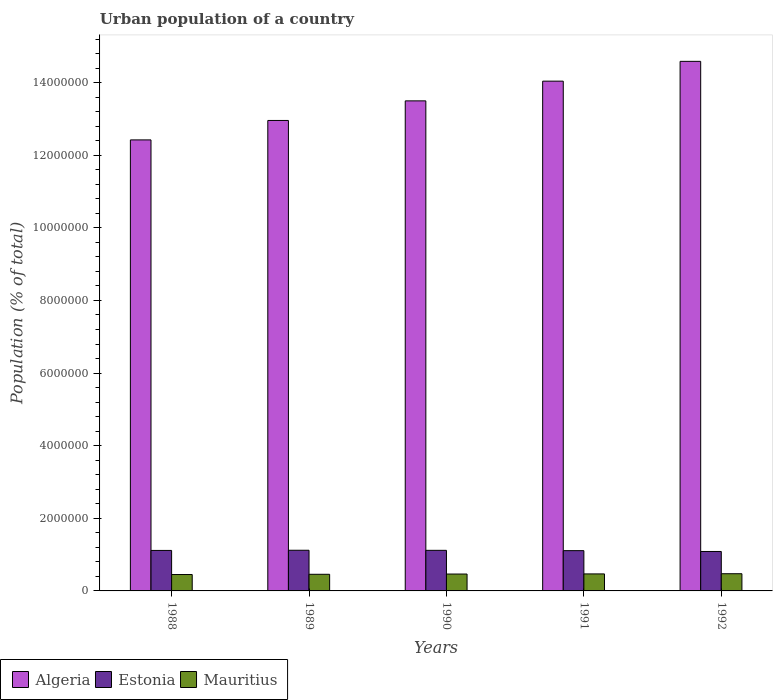How many different coloured bars are there?
Your response must be concise. 3. How many groups of bars are there?
Ensure brevity in your answer.  5. Are the number of bars on each tick of the X-axis equal?
Offer a very short reply. Yes. How many bars are there on the 4th tick from the right?
Provide a succinct answer. 3. What is the label of the 5th group of bars from the left?
Your response must be concise. 1992. What is the urban population in Mauritius in 1992?
Give a very brief answer. 4.73e+05. Across all years, what is the maximum urban population in Algeria?
Provide a short and direct response. 1.46e+07. Across all years, what is the minimum urban population in Algeria?
Ensure brevity in your answer.  1.24e+07. In which year was the urban population in Mauritius minimum?
Your response must be concise. 1988. What is the total urban population in Mauritius in the graph?
Offer a very short reply. 2.32e+06. What is the difference between the urban population in Estonia in 1989 and that in 1990?
Ensure brevity in your answer.  2143. What is the difference between the urban population in Estonia in 1988 and the urban population in Algeria in 1992?
Your answer should be compact. -1.35e+07. What is the average urban population in Mauritius per year?
Ensure brevity in your answer.  4.63e+05. In the year 1988, what is the difference between the urban population in Algeria and urban population in Mauritius?
Your response must be concise. 1.20e+07. In how many years, is the urban population in Algeria greater than 13200000 %?
Provide a succinct answer. 3. What is the ratio of the urban population in Mauritius in 1991 to that in 1992?
Provide a succinct answer. 0.99. Is the urban population in Mauritius in 1990 less than that in 1991?
Provide a succinct answer. Yes. Is the difference between the urban population in Algeria in 1990 and 1992 greater than the difference between the urban population in Mauritius in 1990 and 1992?
Your response must be concise. No. What is the difference between the highest and the second highest urban population in Mauritius?
Your response must be concise. 4861. What is the difference between the highest and the lowest urban population in Estonia?
Give a very brief answer. 3.35e+04. Is the sum of the urban population in Algeria in 1989 and 1990 greater than the maximum urban population in Estonia across all years?
Offer a very short reply. Yes. What does the 1st bar from the left in 1992 represents?
Your response must be concise. Algeria. What does the 2nd bar from the right in 1991 represents?
Offer a terse response. Estonia. Is it the case that in every year, the sum of the urban population in Algeria and urban population in Estonia is greater than the urban population in Mauritius?
Offer a very short reply. Yes. Are all the bars in the graph horizontal?
Provide a short and direct response. No. How many years are there in the graph?
Your answer should be very brief. 5. Are the values on the major ticks of Y-axis written in scientific E-notation?
Provide a succinct answer. No. Where does the legend appear in the graph?
Keep it short and to the point. Bottom left. How many legend labels are there?
Ensure brevity in your answer.  3. How are the legend labels stacked?
Offer a very short reply. Horizontal. What is the title of the graph?
Provide a short and direct response. Urban population of a country. Does "South Asia" appear as one of the legend labels in the graph?
Offer a terse response. No. What is the label or title of the X-axis?
Ensure brevity in your answer.  Years. What is the label or title of the Y-axis?
Your answer should be compact. Population (% of total). What is the Population (% of total) of Algeria in 1988?
Give a very brief answer. 1.24e+07. What is the Population (% of total) in Estonia in 1988?
Offer a very short reply. 1.12e+06. What is the Population (% of total) in Mauritius in 1988?
Offer a terse response. 4.51e+05. What is the Population (% of total) of Algeria in 1989?
Offer a terse response. 1.30e+07. What is the Population (% of total) of Estonia in 1989?
Your answer should be compact. 1.12e+06. What is the Population (% of total) in Mauritius in 1989?
Give a very brief answer. 4.58e+05. What is the Population (% of total) in Algeria in 1990?
Ensure brevity in your answer.  1.35e+07. What is the Population (% of total) of Estonia in 1990?
Offer a terse response. 1.12e+06. What is the Population (% of total) in Mauritius in 1990?
Ensure brevity in your answer.  4.65e+05. What is the Population (% of total) in Algeria in 1991?
Provide a succinct answer. 1.40e+07. What is the Population (% of total) of Estonia in 1991?
Offer a terse response. 1.11e+06. What is the Population (% of total) in Mauritius in 1991?
Ensure brevity in your answer.  4.69e+05. What is the Population (% of total) in Algeria in 1992?
Your response must be concise. 1.46e+07. What is the Population (% of total) of Estonia in 1992?
Your answer should be very brief. 1.09e+06. What is the Population (% of total) in Mauritius in 1992?
Your answer should be compact. 4.73e+05. Across all years, what is the maximum Population (% of total) in Algeria?
Keep it short and to the point. 1.46e+07. Across all years, what is the maximum Population (% of total) of Estonia?
Keep it short and to the point. 1.12e+06. Across all years, what is the maximum Population (% of total) in Mauritius?
Provide a succinct answer. 4.73e+05. Across all years, what is the minimum Population (% of total) of Algeria?
Make the answer very short. 1.24e+07. Across all years, what is the minimum Population (% of total) in Estonia?
Offer a terse response. 1.09e+06. Across all years, what is the minimum Population (% of total) of Mauritius?
Offer a terse response. 4.51e+05. What is the total Population (% of total) of Algeria in the graph?
Make the answer very short. 6.75e+07. What is the total Population (% of total) of Estonia in the graph?
Give a very brief answer. 5.55e+06. What is the total Population (% of total) of Mauritius in the graph?
Offer a terse response. 2.32e+06. What is the difference between the Population (% of total) of Algeria in 1988 and that in 1989?
Ensure brevity in your answer.  -5.35e+05. What is the difference between the Population (% of total) in Estonia in 1988 and that in 1989?
Offer a very short reply. -4841. What is the difference between the Population (% of total) of Mauritius in 1988 and that in 1989?
Provide a short and direct response. -6782. What is the difference between the Population (% of total) in Algeria in 1988 and that in 1990?
Keep it short and to the point. -1.08e+06. What is the difference between the Population (% of total) in Estonia in 1988 and that in 1990?
Provide a short and direct response. -2698. What is the difference between the Population (% of total) in Mauritius in 1988 and that in 1990?
Your answer should be very brief. -1.34e+04. What is the difference between the Population (% of total) in Algeria in 1988 and that in 1991?
Offer a terse response. -1.62e+06. What is the difference between the Population (% of total) in Estonia in 1988 and that in 1991?
Your answer should be very brief. 5789. What is the difference between the Population (% of total) of Mauritius in 1988 and that in 1991?
Give a very brief answer. -1.71e+04. What is the difference between the Population (% of total) of Algeria in 1988 and that in 1992?
Your response must be concise. -2.16e+06. What is the difference between the Population (% of total) in Estonia in 1988 and that in 1992?
Offer a very short reply. 2.87e+04. What is the difference between the Population (% of total) in Mauritius in 1988 and that in 1992?
Your answer should be compact. -2.20e+04. What is the difference between the Population (% of total) in Algeria in 1989 and that in 1990?
Your response must be concise. -5.40e+05. What is the difference between the Population (% of total) of Estonia in 1989 and that in 1990?
Your response must be concise. 2143. What is the difference between the Population (% of total) in Mauritius in 1989 and that in 1990?
Give a very brief answer. -6621. What is the difference between the Population (% of total) in Algeria in 1989 and that in 1991?
Offer a terse response. -1.08e+06. What is the difference between the Population (% of total) of Estonia in 1989 and that in 1991?
Your response must be concise. 1.06e+04. What is the difference between the Population (% of total) in Mauritius in 1989 and that in 1991?
Offer a terse response. -1.03e+04. What is the difference between the Population (% of total) in Algeria in 1989 and that in 1992?
Your response must be concise. -1.63e+06. What is the difference between the Population (% of total) in Estonia in 1989 and that in 1992?
Give a very brief answer. 3.35e+04. What is the difference between the Population (% of total) of Mauritius in 1989 and that in 1992?
Give a very brief answer. -1.52e+04. What is the difference between the Population (% of total) of Algeria in 1990 and that in 1991?
Your answer should be very brief. -5.43e+05. What is the difference between the Population (% of total) in Estonia in 1990 and that in 1991?
Provide a short and direct response. 8487. What is the difference between the Population (% of total) in Mauritius in 1990 and that in 1991?
Offer a very short reply. -3728. What is the difference between the Population (% of total) in Algeria in 1990 and that in 1992?
Your answer should be very brief. -1.09e+06. What is the difference between the Population (% of total) of Estonia in 1990 and that in 1992?
Keep it short and to the point. 3.14e+04. What is the difference between the Population (% of total) of Mauritius in 1990 and that in 1992?
Give a very brief answer. -8589. What is the difference between the Population (% of total) of Algeria in 1991 and that in 1992?
Keep it short and to the point. -5.45e+05. What is the difference between the Population (% of total) of Estonia in 1991 and that in 1992?
Keep it short and to the point. 2.29e+04. What is the difference between the Population (% of total) in Mauritius in 1991 and that in 1992?
Provide a succinct answer. -4861. What is the difference between the Population (% of total) of Algeria in 1988 and the Population (% of total) of Estonia in 1989?
Provide a short and direct response. 1.13e+07. What is the difference between the Population (% of total) of Algeria in 1988 and the Population (% of total) of Mauritius in 1989?
Your response must be concise. 1.20e+07. What is the difference between the Population (% of total) in Estonia in 1988 and the Population (% of total) in Mauritius in 1989?
Provide a succinct answer. 6.57e+05. What is the difference between the Population (% of total) of Algeria in 1988 and the Population (% of total) of Estonia in 1990?
Provide a succinct answer. 1.13e+07. What is the difference between the Population (% of total) in Algeria in 1988 and the Population (% of total) in Mauritius in 1990?
Provide a succinct answer. 1.20e+07. What is the difference between the Population (% of total) of Estonia in 1988 and the Population (% of total) of Mauritius in 1990?
Give a very brief answer. 6.50e+05. What is the difference between the Population (% of total) of Algeria in 1988 and the Population (% of total) of Estonia in 1991?
Give a very brief answer. 1.13e+07. What is the difference between the Population (% of total) of Algeria in 1988 and the Population (% of total) of Mauritius in 1991?
Offer a very short reply. 1.20e+07. What is the difference between the Population (% of total) of Estonia in 1988 and the Population (% of total) of Mauritius in 1991?
Offer a very short reply. 6.47e+05. What is the difference between the Population (% of total) in Algeria in 1988 and the Population (% of total) in Estonia in 1992?
Provide a succinct answer. 1.13e+07. What is the difference between the Population (% of total) of Algeria in 1988 and the Population (% of total) of Mauritius in 1992?
Ensure brevity in your answer.  1.19e+07. What is the difference between the Population (% of total) of Estonia in 1988 and the Population (% of total) of Mauritius in 1992?
Provide a short and direct response. 6.42e+05. What is the difference between the Population (% of total) in Algeria in 1989 and the Population (% of total) in Estonia in 1990?
Give a very brief answer. 1.18e+07. What is the difference between the Population (% of total) in Algeria in 1989 and the Population (% of total) in Mauritius in 1990?
Provide a succinct answer. 1.25e+07. What is the difference between the Population (% of total) in Estonia in 1989 and the Population (% of total) in Mauritius in 1990?
Provide a succinct answer. 6.55e+05. What is the difference between the Population (% of total) in Algeria in 1989 and the Population (% of total) in Estonia in 1991?
Provide a short and direct response. 1.18e+07. What is the difference between the Population (% of total) of Algeria in 1989 and the Population (% of total) of Mauritius in 1991?
Your answer should be very brief. 1.25e+07. What is the difference between the Population (% of total) in Estonia in 1989 and the Population (% of total) in Mauritius in 1991?
Make the answer very short. 6.51e+05. What is the difference between the Population (% of total) in Algeria in 1989 and the Population (% of total) in Estonia in 1992?
Ensure brevity in your answer.  1.19e+07. What is the difference between the Population (% of total) in Algeria in 1989 and the Population (% of total) in Mauritius in 1992?
Provide a succinct answer. 1.25e+07. What is the difference between the Population (% of total) of Estonia in 1989 and the Population (% of total) of Mauritius in 1992?
Provide a short and direct response. 6.46e+05. What is the difference between the Population (% of total) in Algeria in 1990 and the Population (% of total) in Estonia in 1991?
Ensure brevity in your answer.  1.24e+07. What is the difference between the Population (% of total) in Algeria in 1990 and the Population (% of total) in Mauritius in 1991?
Give a very brief answer. 1.30e+07. What is the difference between the Population (% of total) of Estonia in 1990 and the Population (% of total) of Mauritius in 1991?
Your answer should be very brief. 6.49e+05. What is the difference between the Population (% of total) in Algeria in 1990 and the Population (% of total) in Estonia in 1992?
Give a very brief answer. 1.24e+07. What is the difference between the Population (% of total) of Algeria in 1990 and the Population (% of total) of Mauritius in 1992?
Offer a very short reply. 1.30e+07. What is the difference between the Population (% of total) of Estonia in 1990 and the Population (% of total) of Mauritius in 1992?
Provide a short and direct response. 6.44e+05. What is the difference between the Population (% of total) in Algeria in 1991 and the Population (% of total) in Estonia in 1992?
Provide a succinct answer. 1.30e+07. What is the difference between the Population (% of total) of Algeria in 1991 and the Population (% of total) of Mauritius in 1992?
Provide a short and direct response. 1.36e+07. What is the difference between the Population (% of total) in Estonia in 1991 and the Population (% of total) in Mauritius in 1992?
Your answer should be compact. 6.36e+05. What is the average Population (% of total) in Algeria per year?
Make the answer very short. 1.35e+07. What is the average Population (% of total) in Estonia per year?
Make the answer very short. 1.11e+06. What is the average Population (% of total) in Mauritius per year?
Ensure brevity in your answer.  4.63e+05. In the year 1988, what is the difference between the Population (% of total) of Algeria and Population (% of total) of Estonia?
Make the answer very short. 1.13e+07. In the year 1988, what is the difference between the Population (% of total) of Algeria and Population (% of total) of Mauritius?
Your answer should be compact. 1.20e+07. In the year 1988, what is the difference between the Population (% of total) in Estonia and Population (% of total) in Mauritius?
Your answer should be compact. 6.64e+05. In the year 1989, what is the difference between the Population (% of total) in Algeria and Population (% of total) in Estonia?
Make the answer very short. 1.18e+07. In the year 1989, what is the difference between the Population (% of total) of Algeria and Population (% of total) of Mauritius?
Provide a short and direct response. 1.25e+07. In the year 1989, what is the difference between the Population (% of total) in Estonia and Population (% of total) in Mauritius?
Your response must be concise. 6.62e+05. In the year 1990, what is the difference between the Population (% of total) in Algeria and Population (% of total) in Estonia?
Make the answer very short. 1.24e+07. In the year 1990, what is the difference between the Population (% of total) in Algeria and Population (% of total) in Mauritius?
Give a very brief answer. 1.30e+07. In the year 1990, what is the difference between the Population (% of total) of Estonia and Population (% of total) of Mauritius?
Provide a succinct answer. 6.53e+05. In the year 1991, what is the difference between the Population (% of total) in Algeria and Population (% of total) in Estonia?
Offer a terse response. 1.29e+07. In the year 1991, what is the difference between the Population (% of total) of Algeria and Population (% of total) of Mauritius?
Your response must be concise. 1.36e+07. In the year 1991, what is the difference between the Population (% of total) in Estonia and Population (% of total) in Mauritius?
Make the answer very short. 6.41e+05. In the year 1992, what is the difference between the Population (% of total) in Algeria and Population (% of total) in Estonia?
Your answer should be compact. 1.35e+07. In the year 1992, what is the difference between the Population (% of total) of Algeria and Population (% of total) of Mauritius?
Keep it short and to the point. 1.41e+07. In the year 1992, what is the difference between the Population (% of total) of Estonia and Population (% of total) of Mauritius?
Offer a very short reply. 6.13e+05. What is the ratio of the Population (% of total) of Algeria in 1988 to that in 1989?
Your answer should be compact. 0.96. What is the ratio of the Population (% of total) of Estonia in 1988 to that in 1989?
Offer a terse response. 1. What is the ratio of the Population (% of total) of Mauritius in 1988 to that in 1989?
Provide a succinct answer. 0.99. What is the ratio of the Population (% of total) in Algeria in 1988 to that in 1990?
Make the answer very short. 0.92. What is the ratio of the Population (% of total) in Estonia in 1988 to that in 1990?
Ensure brevity in your answer.  1. What is the ratio of the Population (% of total) in Mauritius in 1988 to that in 1990?
Make the answer very short. 0.97. What is the ratio of the Population (% of total) in Algeria in 1988 to that in 1991?
Your answer should be very brief. 0.88. What is the ratio of the Population (% of total) of Mauritius in 1988 to that in 1991?
Your response must be concise. 0.96. What is the ratio of the Population (% of total) of Algeria in 1988 to that in 1992?
Keep it short and to the point. 0.85. What is the ratio of the Population (% of total) of Estonia in 1988 to that in 1992?
Your response must be concise. 1.03. What is the ratio of the Population (% of total) in Mauritius in 1988 to that in 1992?
Provide a succinct answer. 0.95. What is the ratio of the Population (% of total) in Algeria in 1989 to that in 1990?
Give a very brief answer. 0.96. What is the ratio of the Population (% of total) of Estonia in 1989 to that in 1990?
Provide a short and direct response. 1. What is the ratio of the Population (% of total) in Mauritius in 1989 to that in 1990?
Provide a short and direct response. 0.99. What is the ratio of the Population (% of total) in Algeria in 1989 to that in 1991?
Provide a succinct answer. 0.92. What is the ratio of the Population (% of total) of Estonia in 1989 to that in 1991?
Keep it short and to the point. 1.01. What is the ratio of the Population (% of total) of Mauritius in 1989 to that in 1991?
Your answer should be very brief. 0.98. What is the ratio of the Population (% of total) in Algeria in 1989 to that in 1992?
Ensure brevity in your answer.  0.89. What is the ratio of the Population (% of total) in Estonia in 1989 to that in 1992?
Your answer should be very brief. 1.03. What is the ratio of the Population (% of total) of Mauritius in 1989 to that in 1992?
Your answer should be compact. 0.97. What is the ratio of the Population (% of total) in Algeria in 1990 to that in 1991?
Your response must be concise. 0.96. What is the ratio of the Population (% of total) in Estonia in 1990 to that in 1991?
Your response must be concise. 1.01. What is the ratio of the Population (% of total) of Algeria in 1990 to that in 1992?
Keep it short and to the point. 0.93. What is the ratio of the Population (% of total) in Estonia in 1990 to that in 1992?
Your answer should be very brief. 1.03. What is the ratio of the Population (% of total) of Mauritius in 1990 to that in 1992?
Your answer should be compact. 0.98. What is the ratio of the Population (% of total) of Algeria in 1991 to that in 1992?
Ensure brevity in your answer.  0.96. What is the ratio of the Population (% of total) of Estonia in 1991 to that in 1992?
Offer a very short reply. 1.02. What is the ratio of the Population (% of total) of Mauritius in 1991 to that in 1992?
Ensure brevity in your answer.  0.99. What is the difference between the highest and the second highest Population (% of total) of Algeria?
Ensure brevity in your answer.  5.45e+05. What is the difference between the highest and the second highest Population (% of total) in Estonia?
Your answer should be compact. 2143. What is the difference between the highest and the second highest Population (% of total) of Mauritius?
Keep it short and to the point. 4861. What is the difference between the highest and the lowest Population (% of total) of Algeria?
Offer a terse response. 2.16e+06. What is the difference between the highest and the lowest Population (% of total) in Estonia?
Offer a very short reply. 3.35e+04. What is the difference between the highest and the lowest Population (% of total) of Mauritius?
Provide a succinct answer. 2.20e+04. 